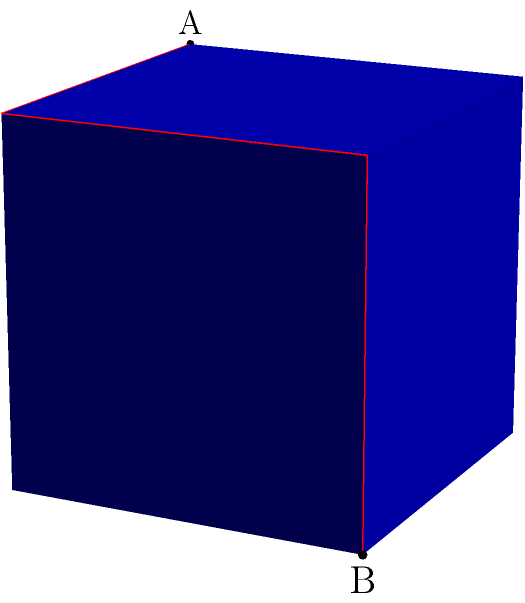Consider a unit cube with point A at coordinates (0,0,1) and point B at (1,1,0). Find the length of the shortest path between A and B along the surface of the cube. How does this relate to the concept of minimum spanning trees in cryptographic network algorithms? To solve this problem, we'll follow these steps:

1) Visualize the cube and the path:
   The shortest path will unfold into a straight line when the cube is unfolded.

2) Identify the path:
   The path goes from A (0,0,1) to (1,0,1), then to (1,1,1), and finally to B (1,1,0).

3) Calculate the length:
   The path consists of three segments:
   - (0,0,1) to (1,0,1): length 1
   - (1,0,1) to (1,1,1): length 1
   - (1,1,1) to (1,1,0): length 1

   Total length = 1 + 1 + 1 = 3

4) Verify using the Pythagorean theorem:
   If we unfold the cube, this path forms the hypotenuse of a right triangle with sides 1 and $\sqrt{2}$.
   $\sqrt{1^2 + (\sqrt{2})^2} = \sqrt{1 + 2} = \sqrt{3}$

5) Relation to cryptographic network algorithms:
   This problem is analogous to finding the shortest path in a network, which is crucial in many cryptographic protocols. In particular, minimum spanning trees are used in network steganography and key distribution algorithms. The process of finding the shortest path on the cube surface is similar to finding the minimum spanning tree in a graph, where edges represent possible communication channels and vertices represent nodes in the network.
Answer: $3$ or $\sqrt{3}$ 